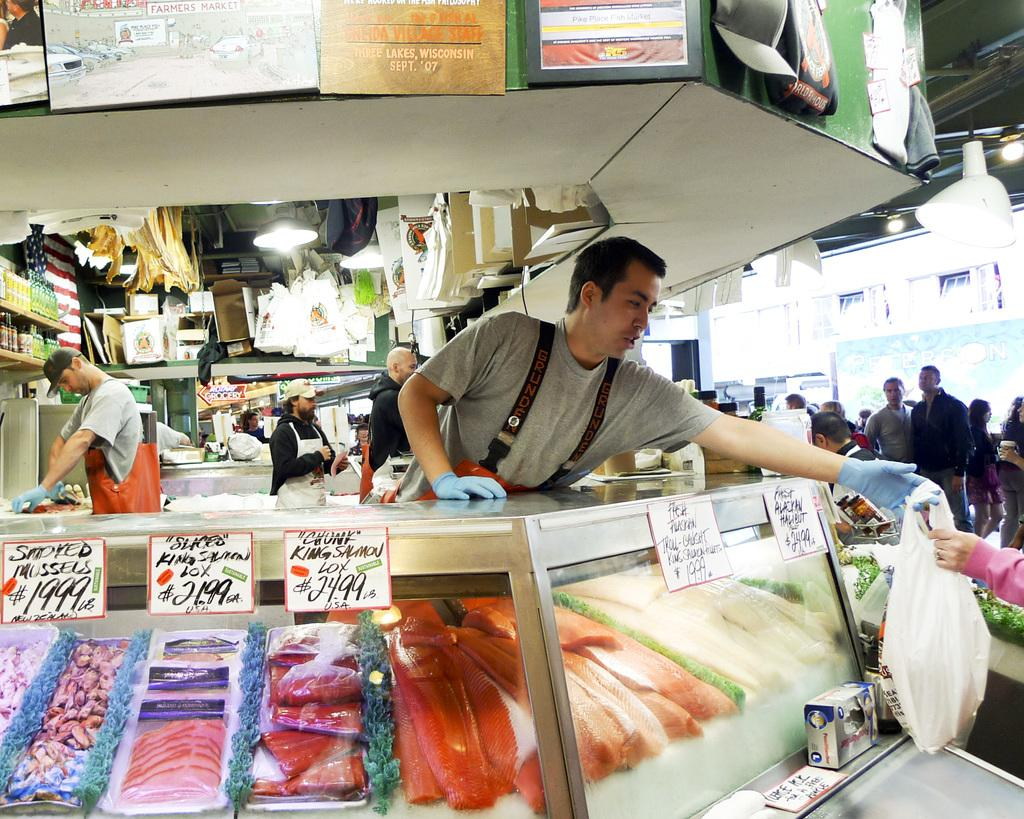Provide a one-sentence caption for the provided image. You can buy chunk king salmon lox for $24.99 per pound at this fish counter. 